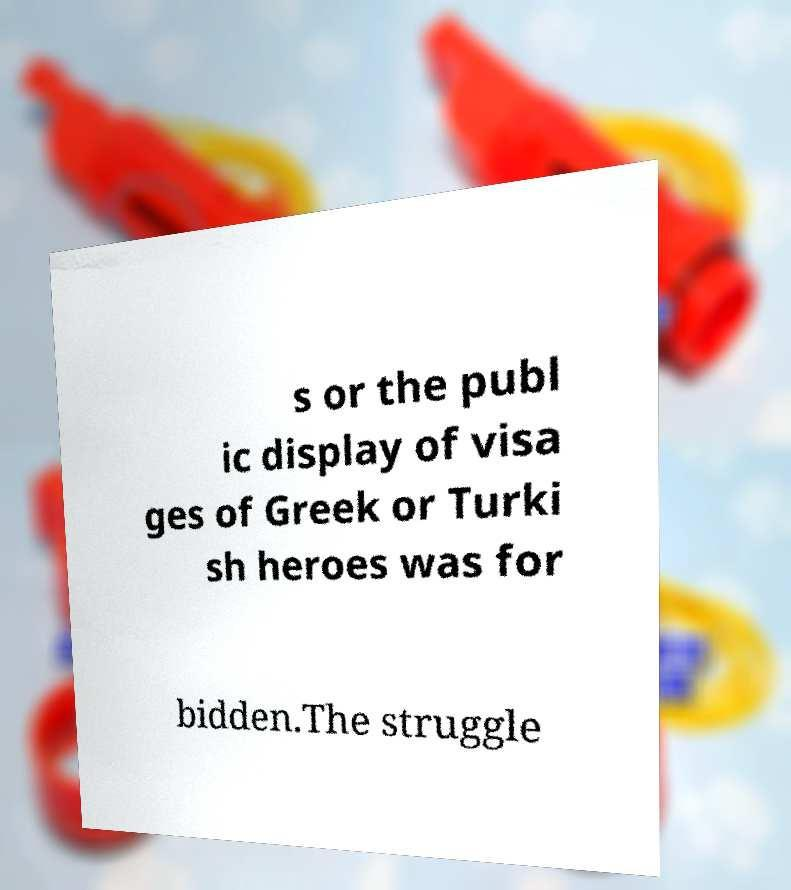Please read and relay the text visible in this image. What does it say? s or the publ ic display of visa ges of Greek or Turki sh heroes was for bidden.The struggle 